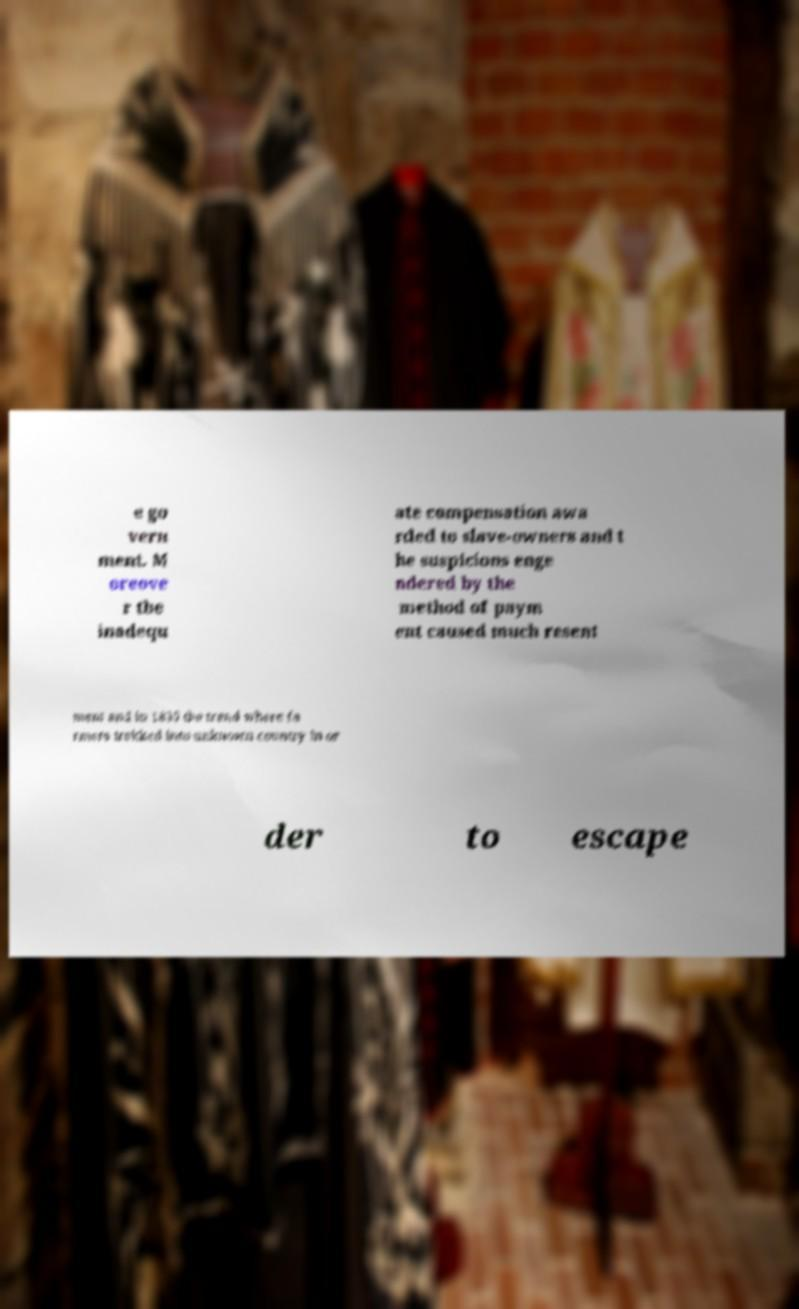Could you extract and type out the text from this image? e go vern ment. M oreove r the inadequ ate compensation awa rded to slave-owners and t he suspicions enge ndered by the method of paym ent caused much resent ment and in 1835 the trend where fa rmers trekked into unknown country in or der to escape 